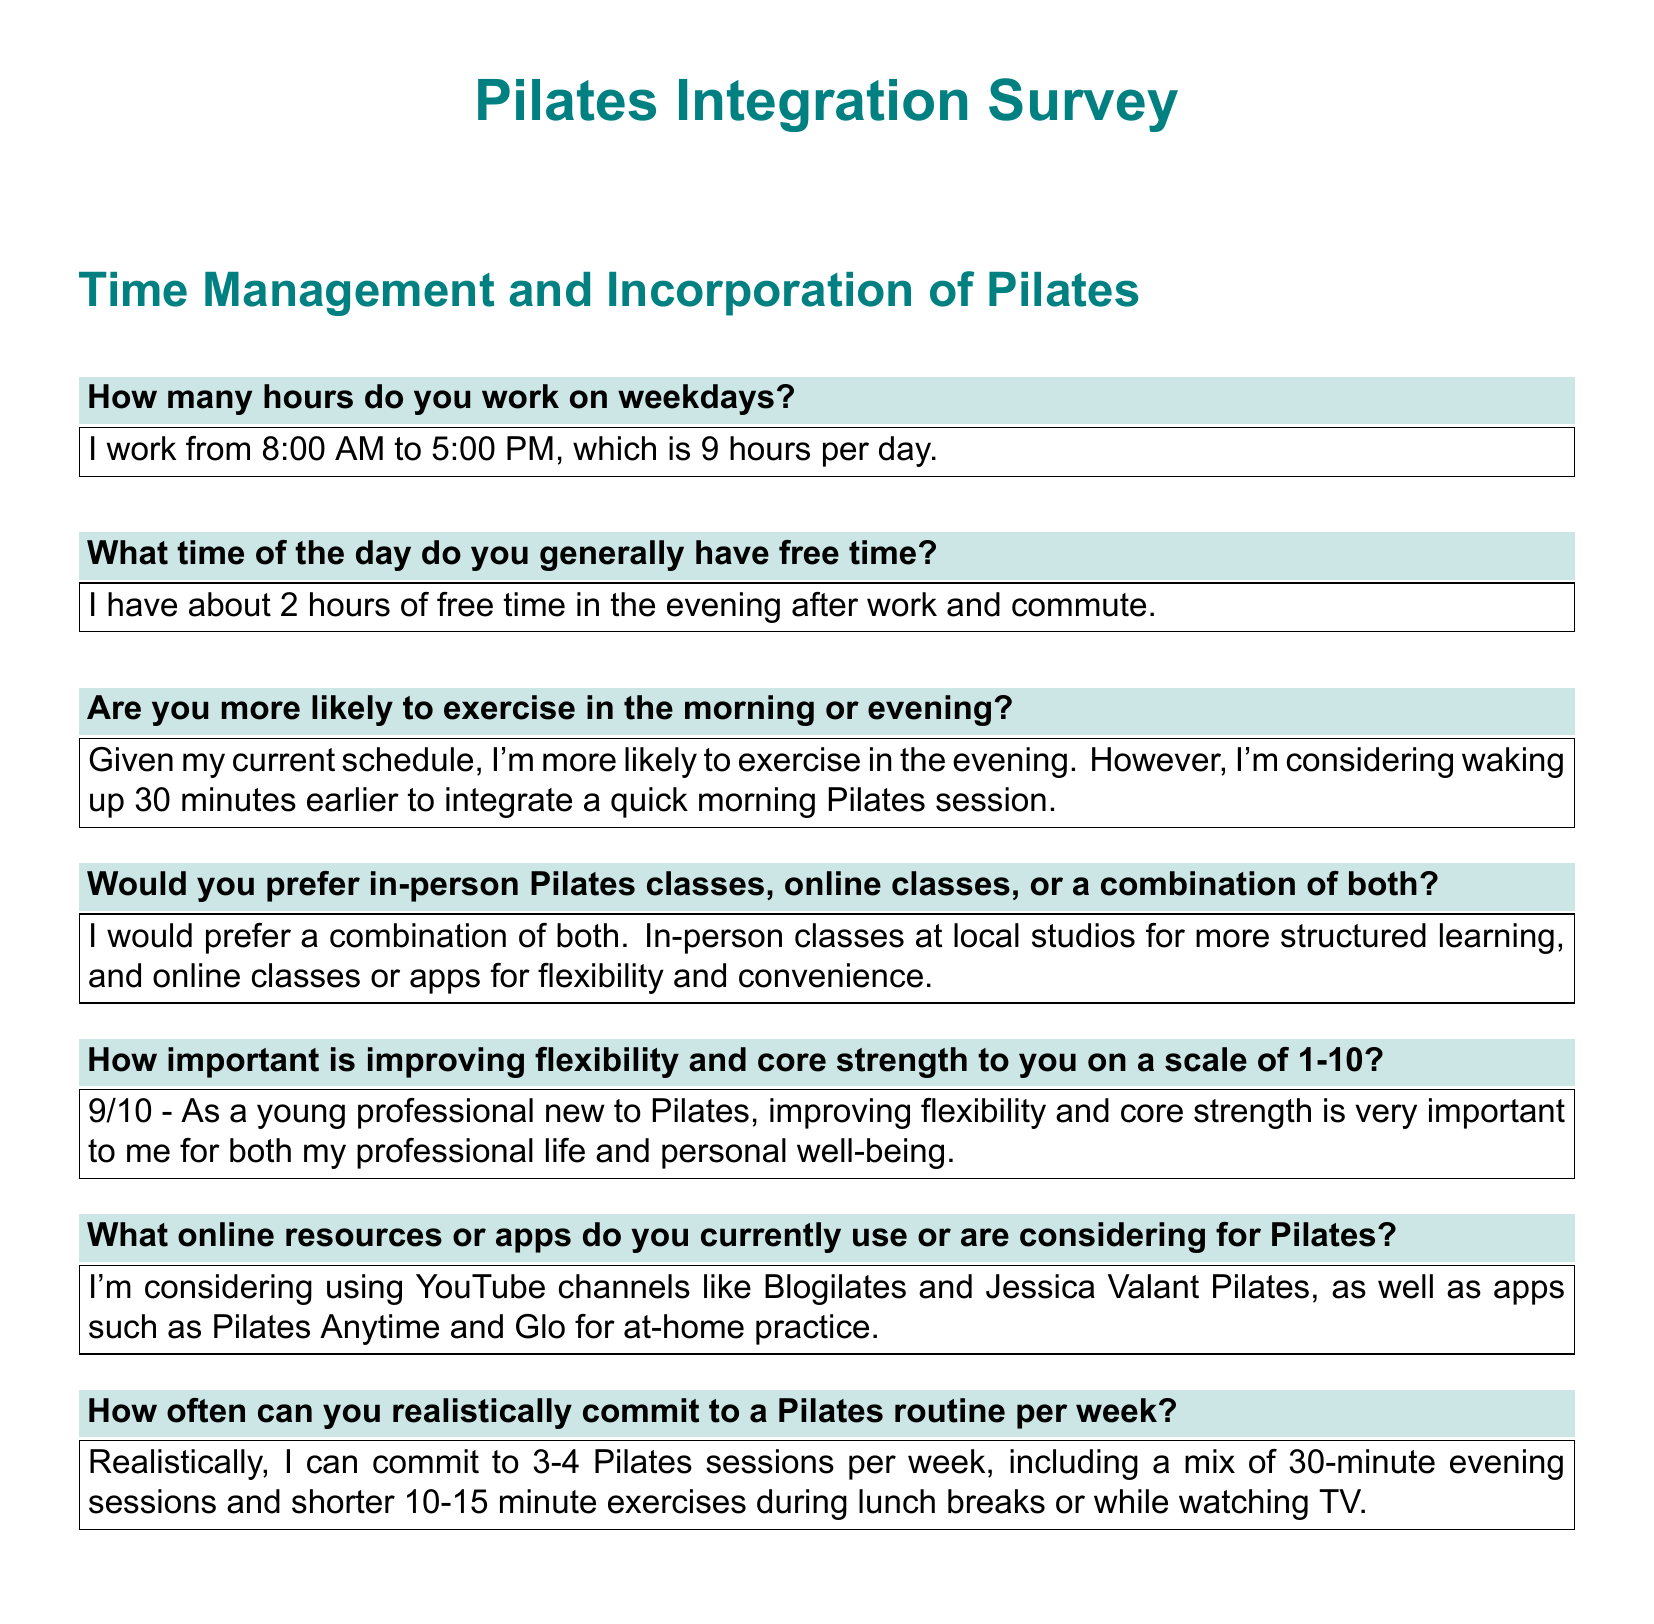How many hours do you work on weekdays? The document states the number of hours worked per day, which is detailed in the response.
Answer: 9 hours What time of the day do you generally have free time? The answer specifies when the individual has free time based on their daily schedule.
Answer: 2 hours in the evening How important is improving flexibility and core strength to you on a scale of 1-10? The answer includes a rating that indicates the level of importance attributed to improving flexibility and core strength.
Answer: 9/10 How often can you realistically commit to a Pilates routine per week? The response mentions a range of sessions per week that the individual can commit to.
Answer: 3-4 sessions What online resources or apps do you currently use or are considering for Pilates? The document lists specific online resources and platforms that the individual is considering for Pilates practice.
Answer: YouTube channels and apps Would you prefer in-person Pilates classes, online classes, or a combination of both? The answer reveals the individual’s preference for taking Pilates classes in different formats.
Answer: A combination of both 